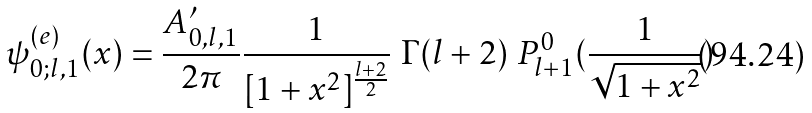Convert formula to latex. <formula><loc_0><loc_0><loc_500><loc_500>\psi _ { 0 ; l , 1 } ^ { ( e ) } ( x ) = \frac { A _ { 0 , l , 1 } ^ { \prime } } { 2 \pi } \frac { 1 } { [ 1 + x ^ { 2 } ] ^ { \frac { l + 2 } { 2 } } } \ \Gamma ( l + 2 ) \ P ^ { 0 } _ { l + 1 } ( \frac { 1 } { \sqrt { 1 + x ^ { 2 } } } )</formula> 